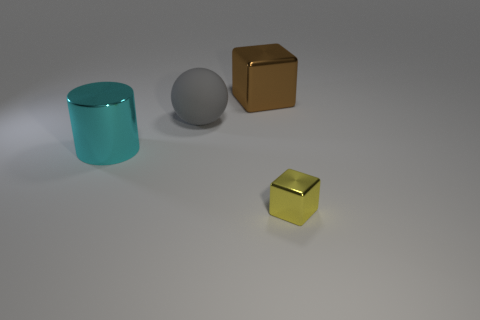Add 1 yellow metallic blocks. How many objects exist? 5 Subtract all cylinders. How many objects are left? 3 Subtract all brown metallic cubes. Subtract all big gray matte things. How many objects are left? 2 Add 4 cyan cylinders. How many cyan cylinders are left? 5 Add 3 big gray things. How many big gray things exist? 4 Subtract 0 purple blocks. How many objects are left? 4 